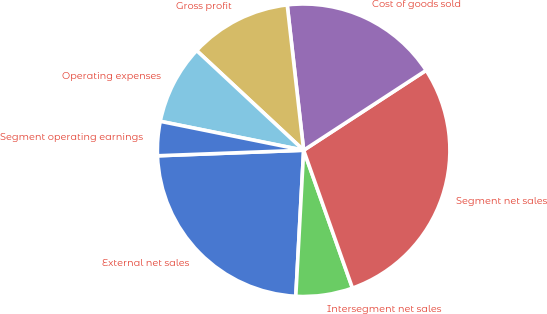Convert chart to OTSL. <chart><loc_0><loc_0><loc_500><loc_500><pie_chart><fcel>External net sales<fcel>Intersegment net sales<fcel>Segment net sales<fcel>Cost of goods sold<fcel>Gross profit<fcel>Operating expenses<fcel>Segment operating earnings<nl><fcel>23.54%<fcel>6.27%<fcel>28.78%<fcel>17.59%<fcel>11.27%<fcel>8.77%<fcel>3.77%<nl></chart> 